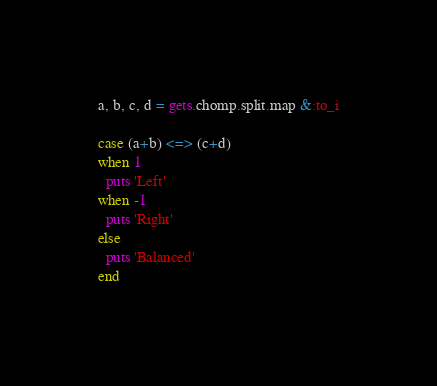Convert code to text. <code><loc_0><loc_0><loc_500><loc_500><_Ruby_>a, b, c, d = gets.chomp.split.map &:to_i

case (a+b) <=> (c+d)
when 1
  puts 'Left'
when -1
  puts 'Right'
else
  puts 'Balanced'
end</code> 